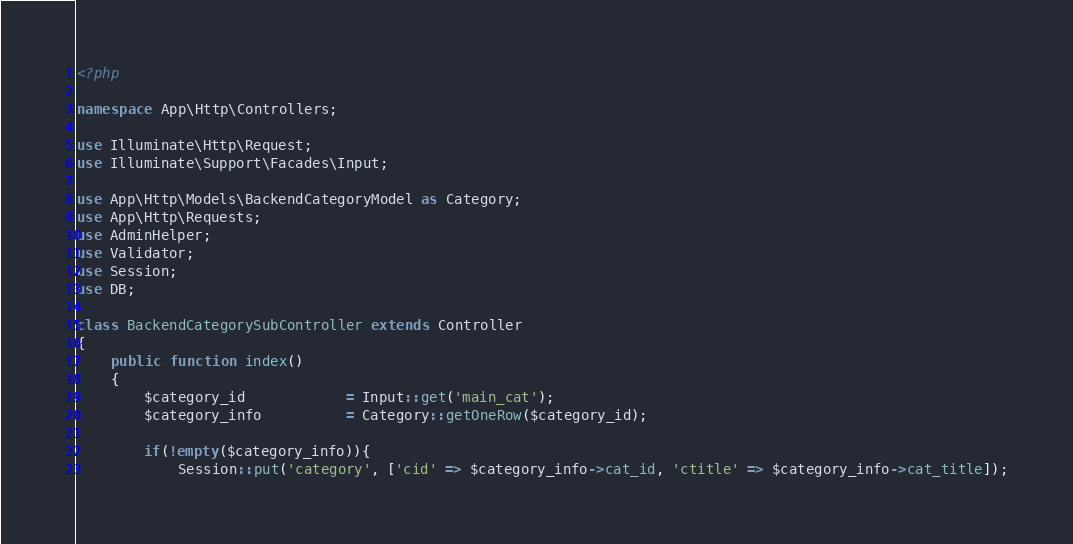<code> <loc_0><loc_0><loc_500><loc_500><_PHP_><?php

namespace App\Http\Controllers;

use Illuminate\Http\Request;
use Illuminate\Support\Facades\Input;

use App\Http\Models\BackendCategoryModel as Category;
use App\Http\Requests;
use AdminHelper;
use Validator;
use Session;
use DB;

class BackendCategorySubController extends Controller
{
    public function index()
    {
        $category_id            = Input::get('main_cat');
        $category_info          = Category::getOneRow($category_id);

        if(!empty($category_info)){
            Session::put('category', ['cid' => $category_info->cat_id, 'ctitle' => $category_info->cat_title]);
</code> 